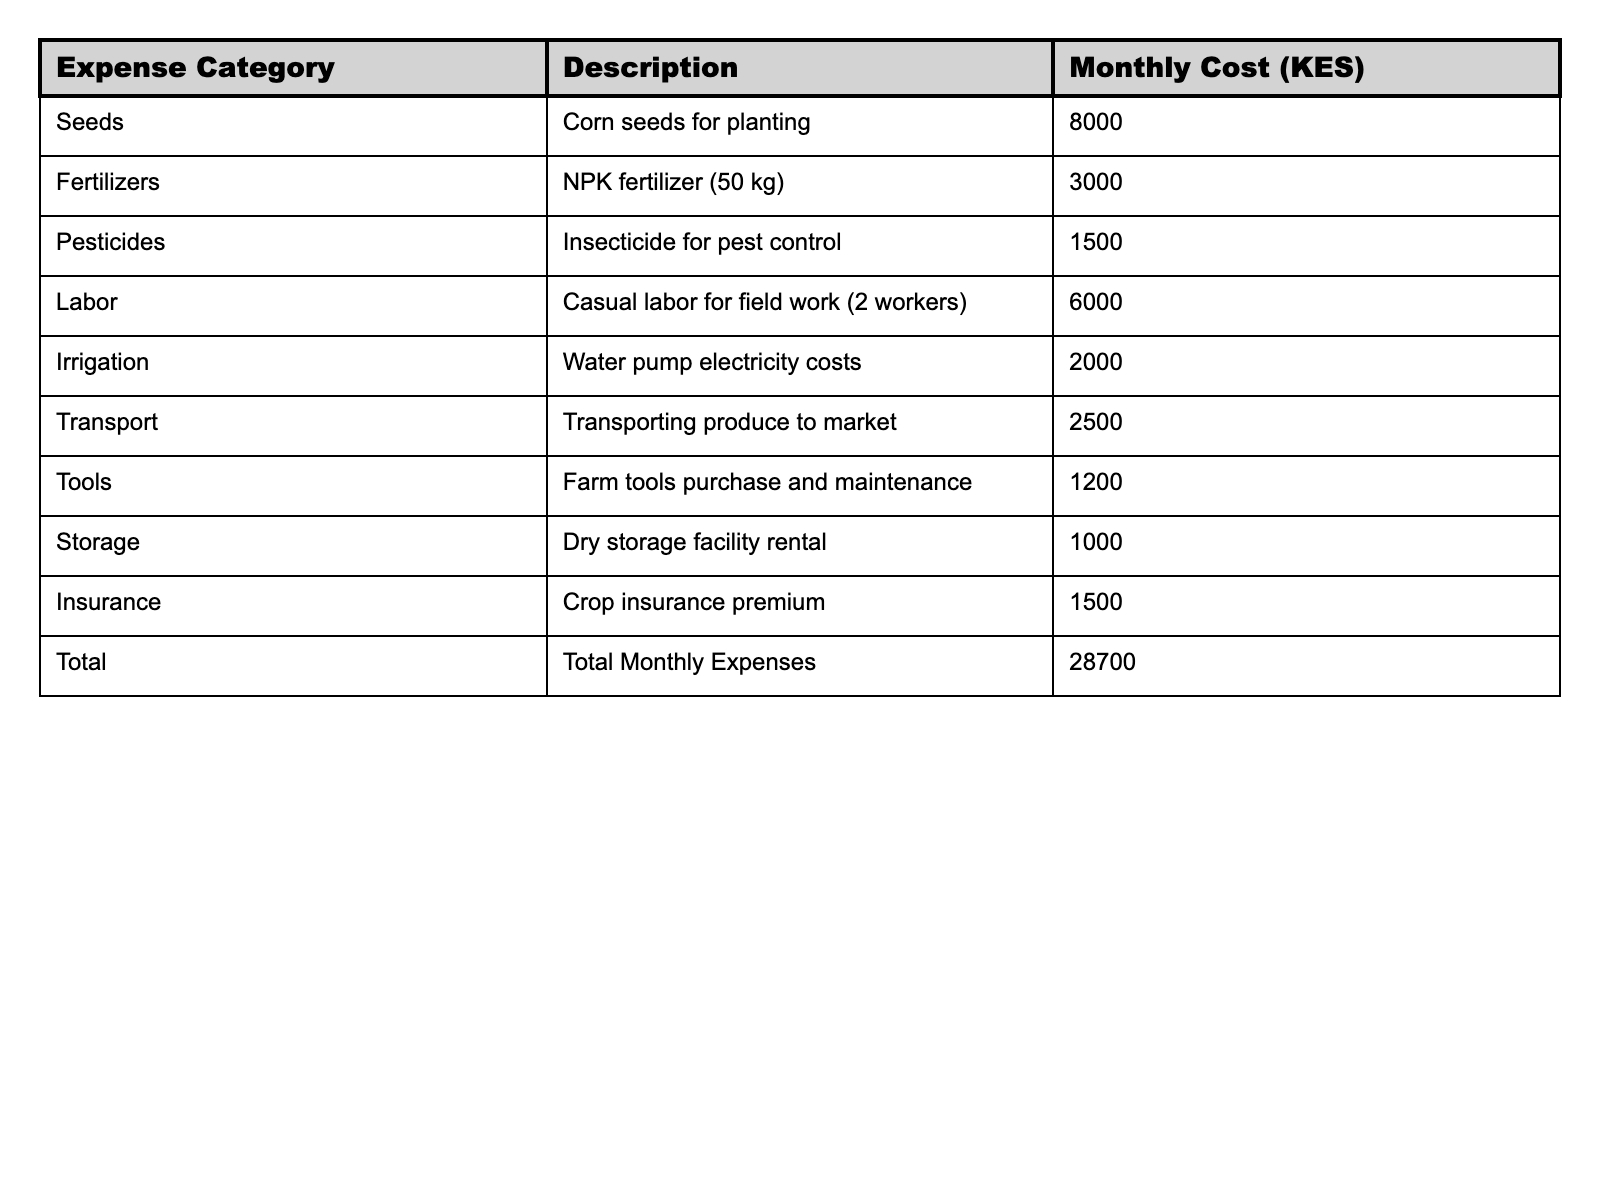What is the total monthly expense for the small-scale farm? The total monthly expense is presented directly in the table under "Total Monthly Expenses," which shows a value of 28,700 KES.
Answer: 28,700 KES How much is spent on fertilizer monthly? The monthly cost for fertilizers is clearly listed in the table under the category "Fertilizers," with a value of 3,000 KES.
Answer: 3,000 KES What are the total costs of seeds and pesticides combined? To find the combined total, we add the cost of seeds (8,000 KES) and the cost of pesticides (1,500 KES) together: 8,000 + 1,500 = 9,500 KES.
Answer: 9,500 KES Is the monthly cost of labor higher than the cost of tools? The monthly cost for labor is 6,000 KES, while the cost for tools is 1,200 KES. Since 6,000 is greater than 1,200, the answer is yes.
Answer: Yes How much do you spend on transport and storage together? Adding the transport cost (2,500 KES) and the storage cost (1,000 KES) gives us the total: 2,500 + 1,000 = 3,500 KES.
Answer: 3,500 KES What is the difference in cost between irrigation and insurance? The monthly cost for irrigation is 2,000 KES and for insurance, it is 1,500 KES. The difference is calculated as 2,000 - 1,500 = 500 KES.
Answer: 500 KES If you had to prioritize reducing costs, which category has the highest expense? Referring to the table, the highest expense category is "Seeds" at 8,000 KES, making it the top priority for potential cost reduction.
Answer: Seeds What is the average cost of all expense categories? To calculate the average, sum all expenses (28,700 KES) and divide by the number of categories (10). Thus, 28,700 / 10 = 2,870 KES.
Answer: 2,870 KES Are the combined costs of fertilizers and pesticides less than the cost of labor? The total for fertilizers (3,000 KES) and pesticides (1,500 KES) is 4,500 KES. Labor costs 6,000 KES. Since 4,500 is less than 6,000, the statement is true.
Answer: True What is the total amount spent on labor and irrigation together? Adding the labor cost (6,000 KES) and the irrigation cost (2,000 KES) gives a combined total of 6,000 + 2,000 = 8,000 KES.
Answer: 8,000 KES 